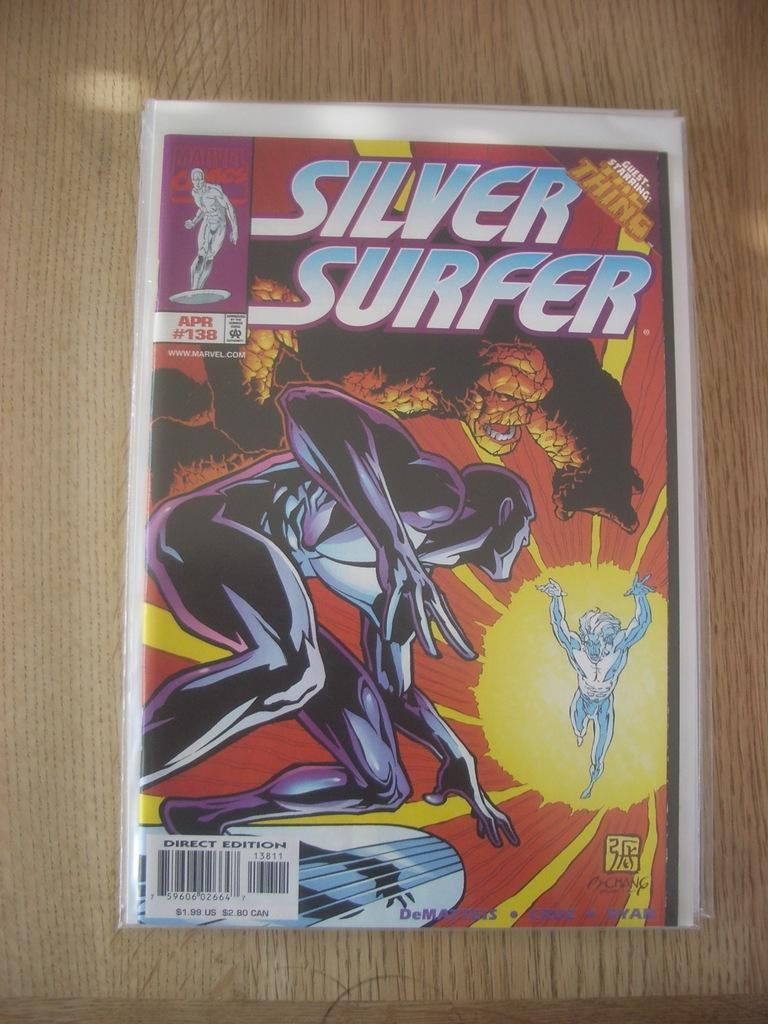<image>
Relay a brief, clear account of the picture shown. A copy of Silver Surfer #138, guest-starring The Thing, sits on a table. 